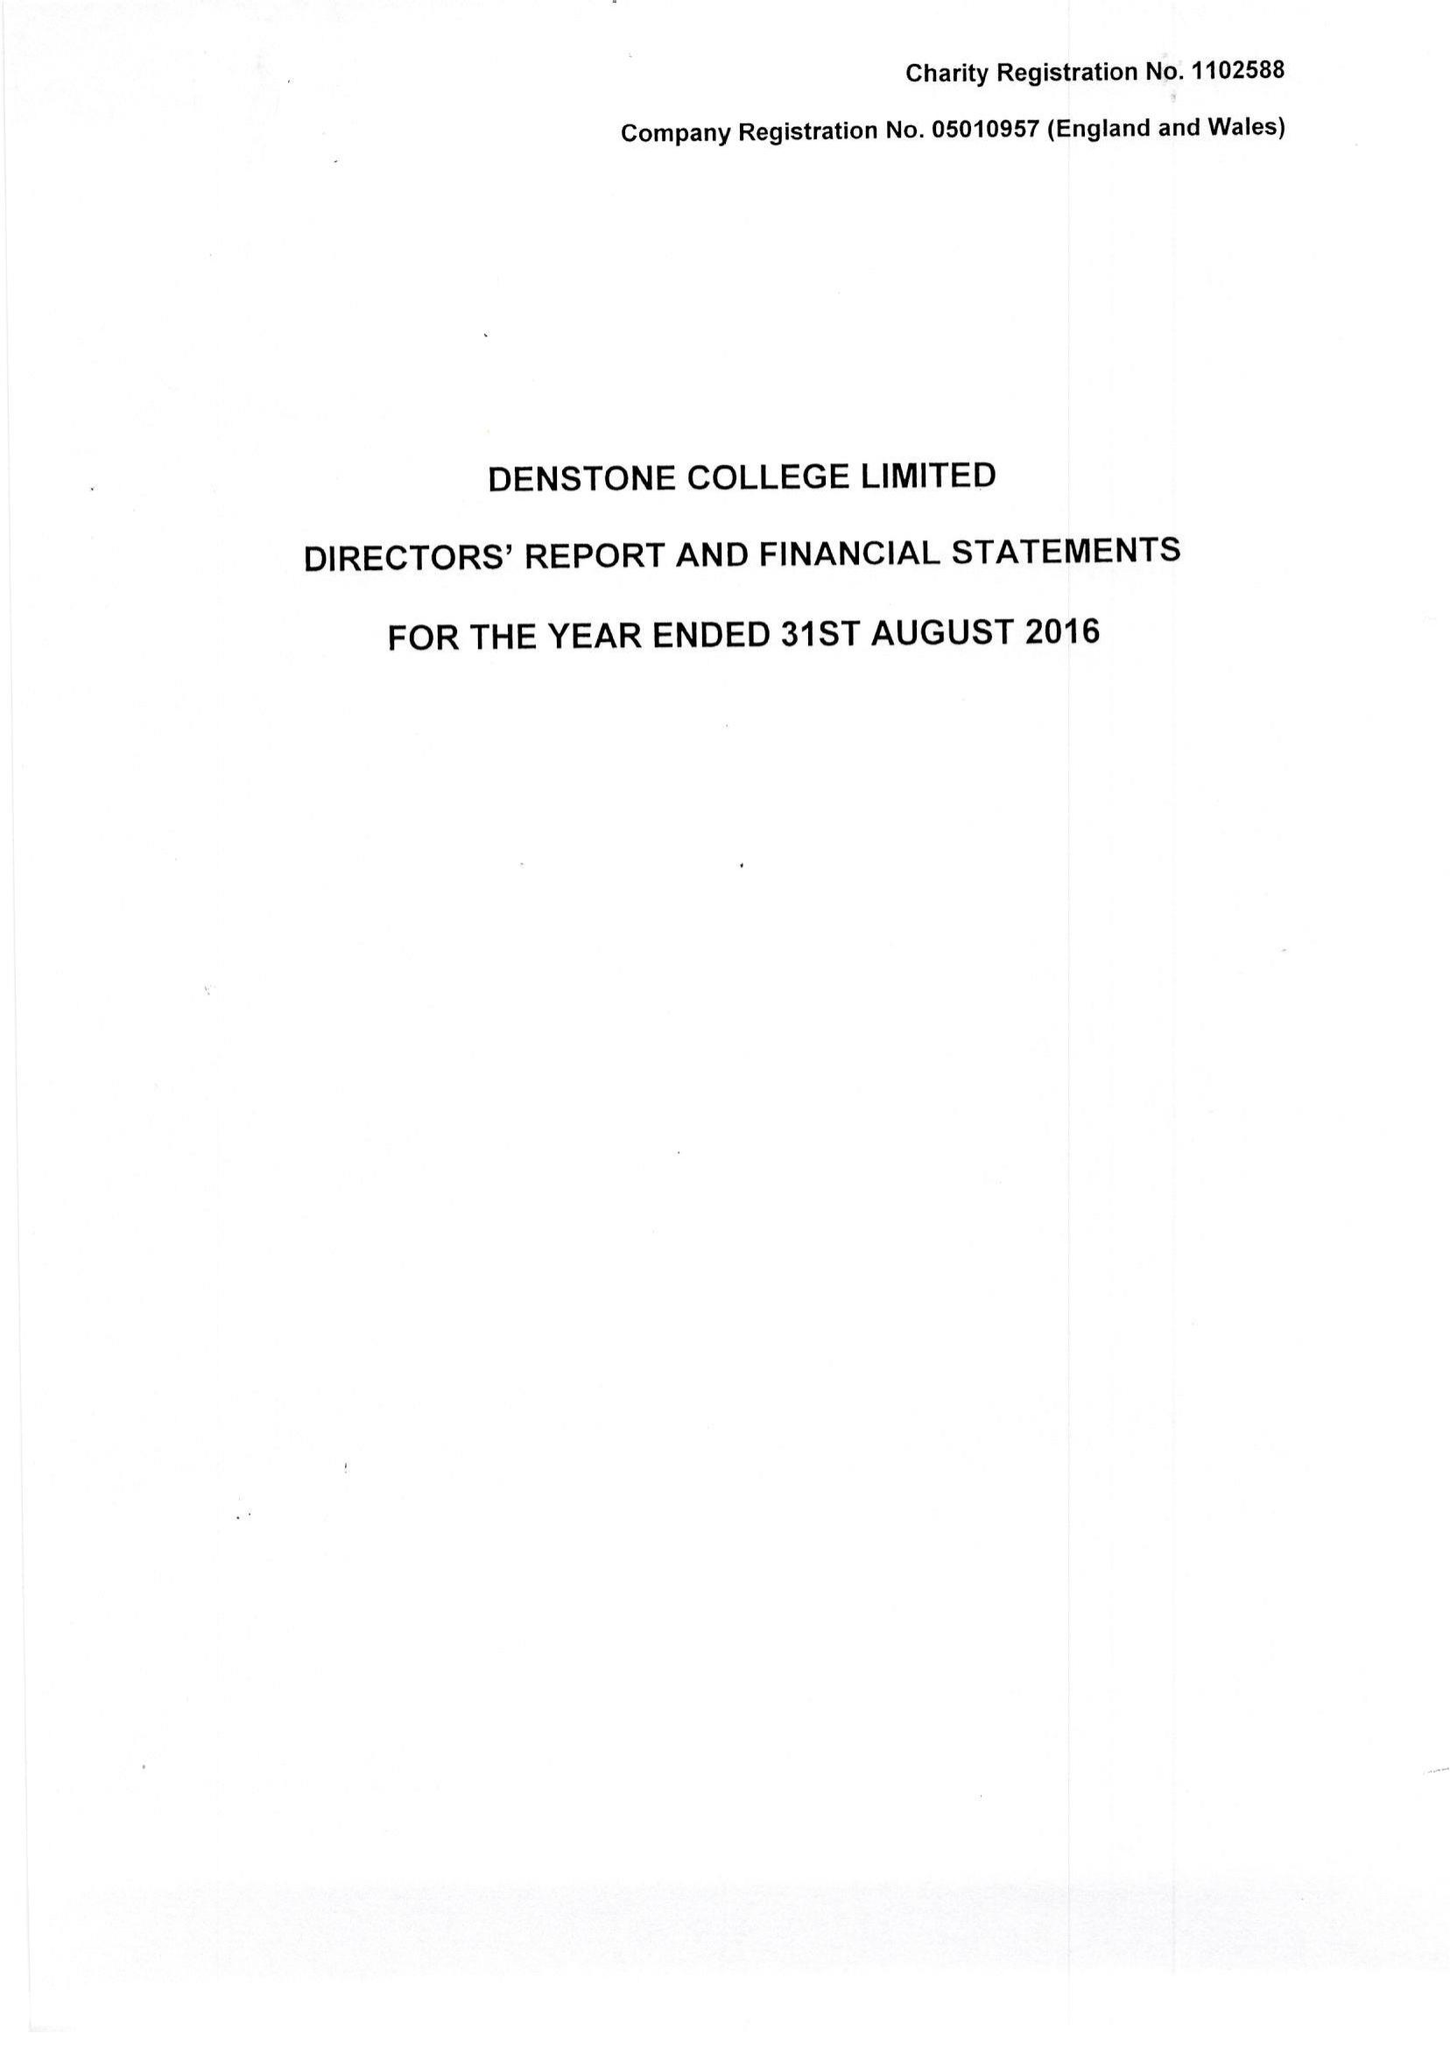What is the value for the report_date?
Answer the question using a single word or phrase. 2016-08-31 